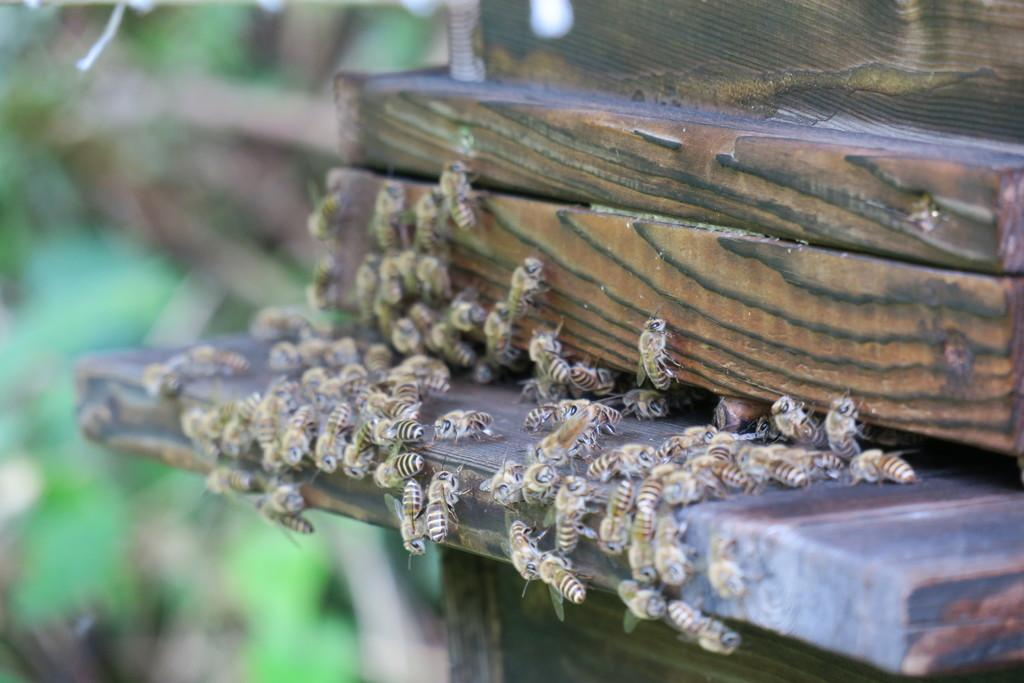What type of animals can be seen in the image? There are bees in the image. What is the bees' location in the image? The bees are on a wood stand. Can you describe the background of the image? The background of the image is blurry. What type of quiet copper man can be seen in the image? There is no quiet copper man present in the image; it features bees on a wood stand. 